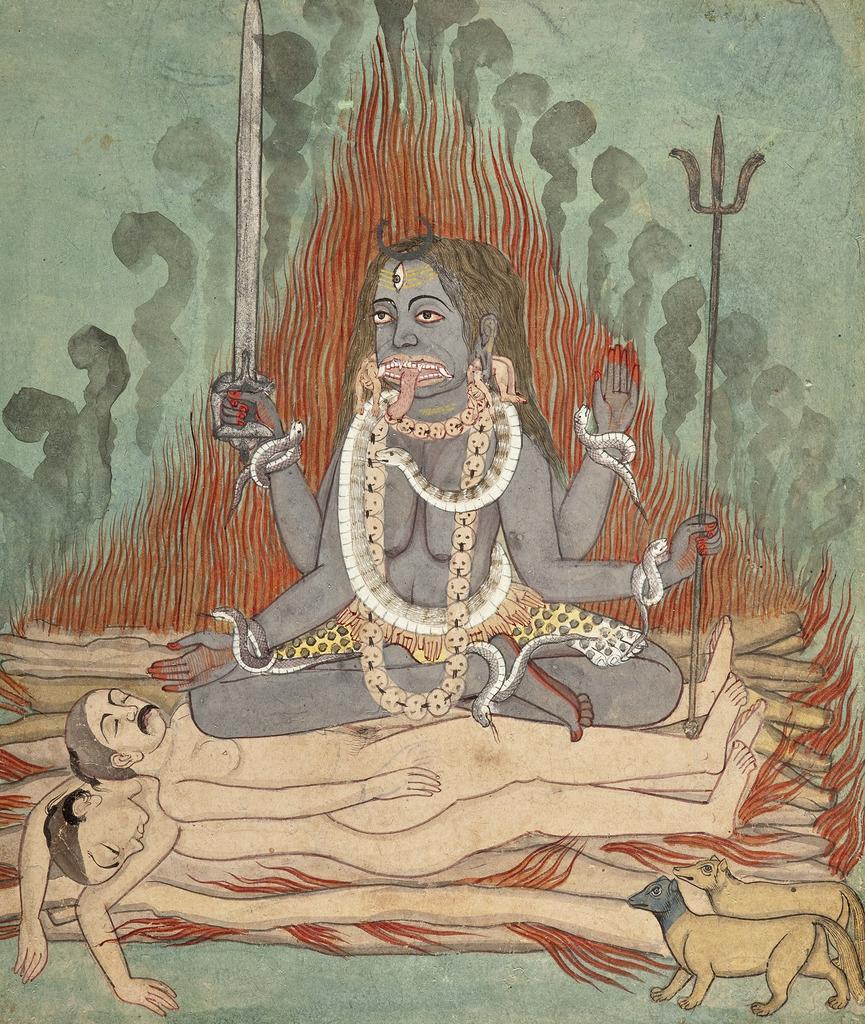In one or two sentences, can you explain what this image depicts? In this picture I can observe a drawing of lord Shiva. I can observe two dead bodies in this drawing. On the right side there are two animals. 